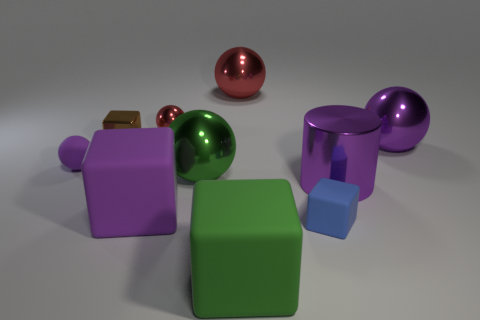Is there any other thing that is the same color as the small rubber cube?
Your answer should be very brief. No. What number of other things are the same size as the green cube?
Give a very brief answer. 5. Are there any green spheres?
Ensure brevity in your answer.  Yes. How big is the block behind the matte thing that is to the left of the shiny cube?
Your answer should be compact. Small. Do the thing that is left of the small metallic cube and the big rubber block that is behind the blue rubber thing have the same color?
Offer a very short reply. Yes. What color is the tiny object that is left of the green metallic object and on the right side of the brown shiny cube?
Offer a very short reply. Red. How many other objects are the same shape as the brown thing?
Your answer should be compact. 3. What is the color of the rubber ball that is the same size as the blue object?
Offer a very short reply. Purple. There is a big matte cube on the right side of the tiny red shiny object; what is its color?
Make the answer very short. Green. There is a red metallic sphere that is to the left of the large green rubber object; are there any large purple balls on the left side of it?
Offer a terse response. No. 